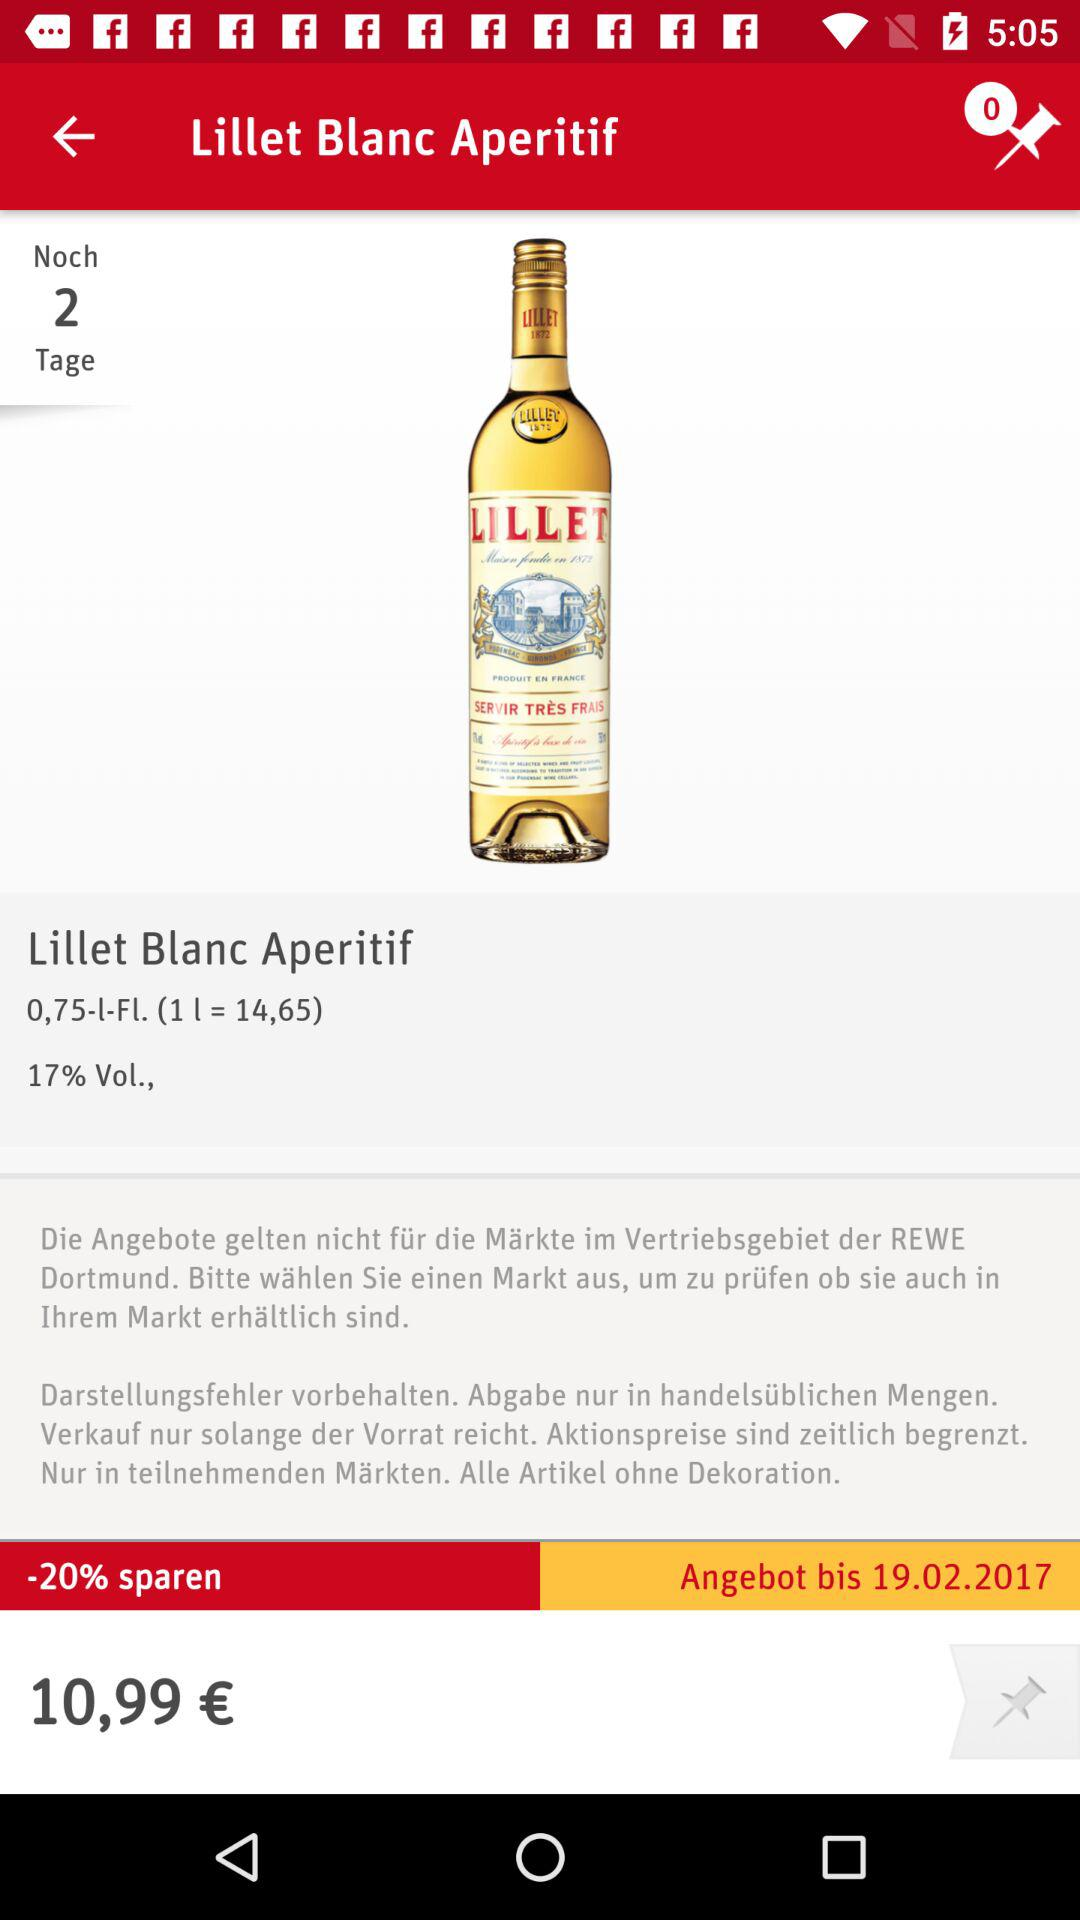How much is the price of the bottle of Lillet Blanc Aperitif?
Answer the question using a single word or phrase. 10,99 € 